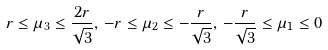Convert formula to latex. <formula><loc_0><loc_0><loc_500><loc_500>r \leq \mu _ { 3 } \leq \frac { 2 r } { \sqrt { 3 } } , \, - r \leq \mu _ { 2 } \leq - \frac { r } { \sqrt { 3 } } , \, - \frac { r } { \sqrt { 3 } } \leq \mu _ { 1 } \leq 0</formula> 